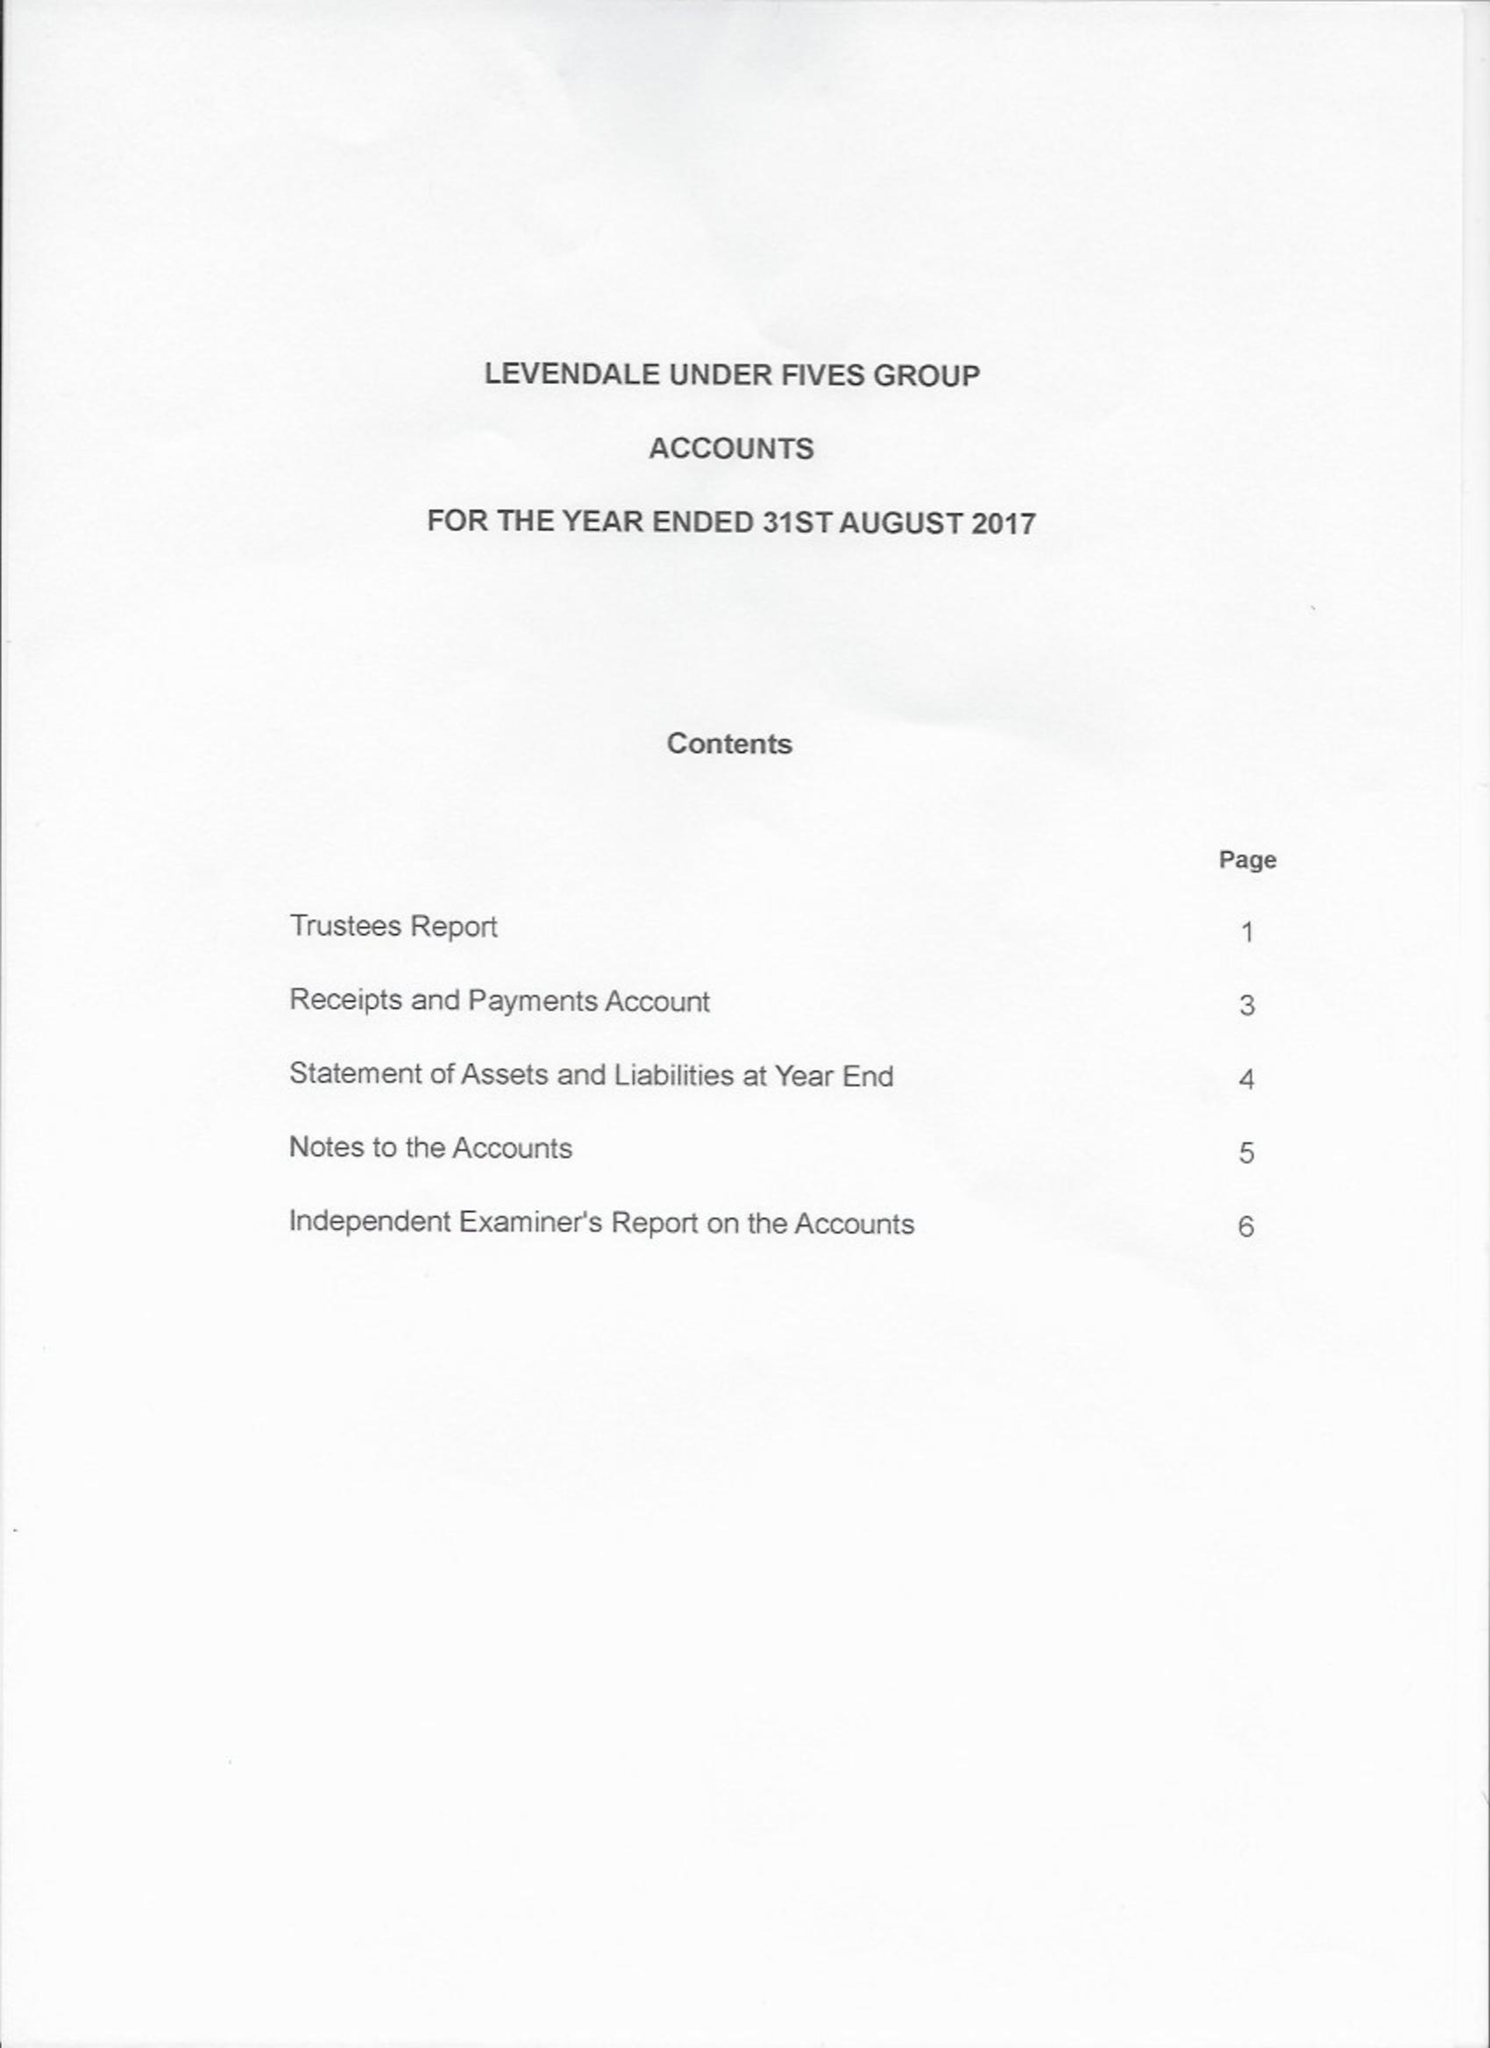What is the value for the spending_annually_in_british_pounds?
Answer the question using a single word or phrase. 37685.00 